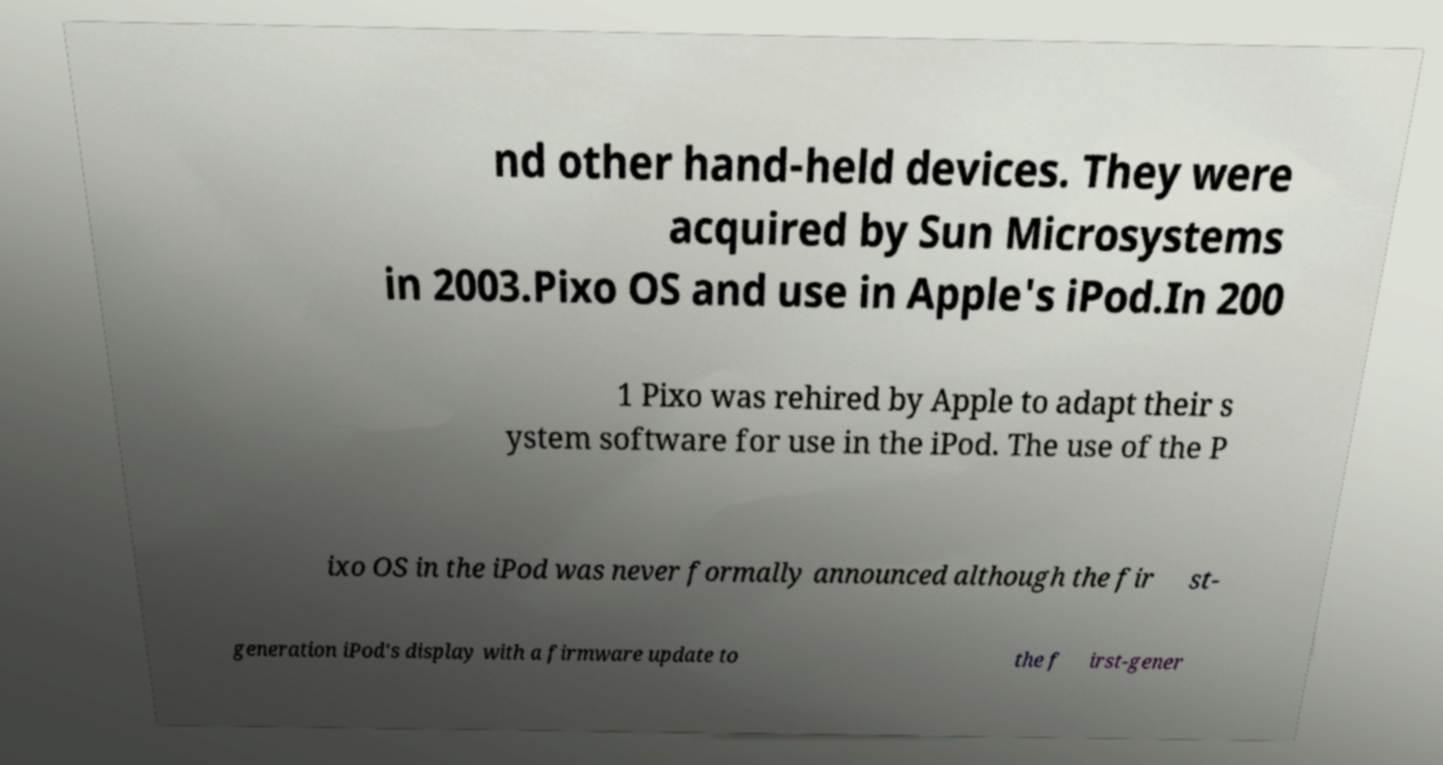Please read and relay the text visible in this image. What does it say? nd other hand-held devices. They were acquired by Sun Microsystems in 2003.Pixo OS and use in Apple's iPod.In 200 1 Pixo was rehired by Apple to adapt their s ystem software for use in the iPod. The use of the P ixo OS in the iPod was never formally announced although the fir st- generation iPod's display with a firmware update to the f irst-gener 